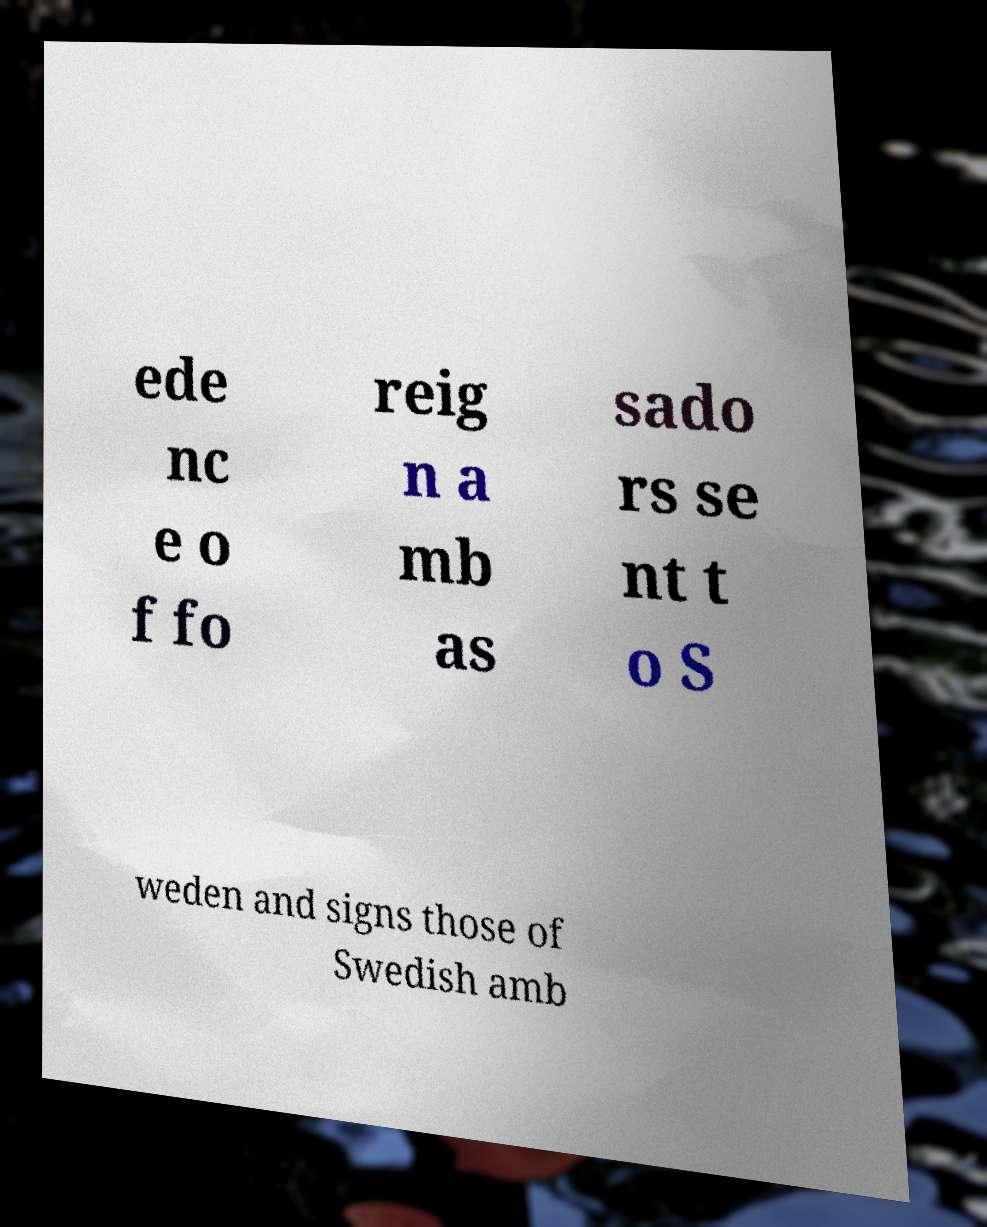There's text embedded in this image that I need extracted. Can you transcribe it verbatim? ede nc e o f fo reig n a mb as sado rs se nt t o S weden and signs those of Swedish amb 